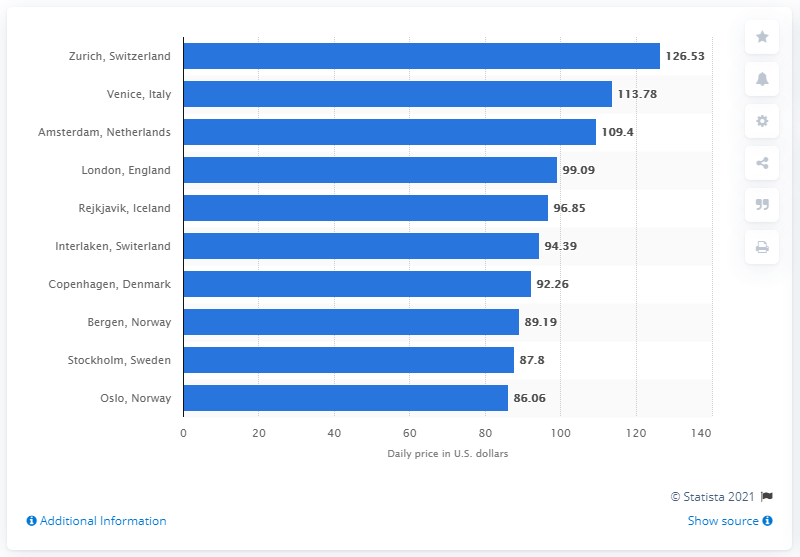Give some essential details in this illustration. The average cost per day to stay in a cheap hostel in Zurich was 126.53 Swiss Francs. 